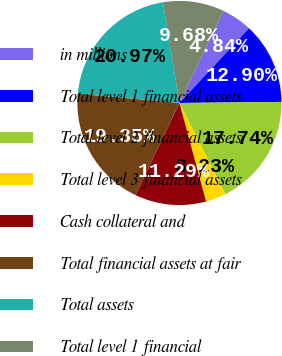Convert chart to OTSL. <chart><loc_0><loc_0><loc_500><loc_500><pie_chart><fcel>in millions<fcel>Total level 1 financial assets<fcel>Total level 2 financial assets<fcel>Total level 3 financial assets<fcel>Cash collateral and<fcel>Total financial assets at fair<fcel>Total assets<fcel>Total level 1 financial<nl><fcel>4.84%<fcel>12.9%<fcel>17.74%<fcel>3.23%<fcel>11.29%<fcel>19.35%<fcel>20.97%<fcel>9.68%<nl></chart> 